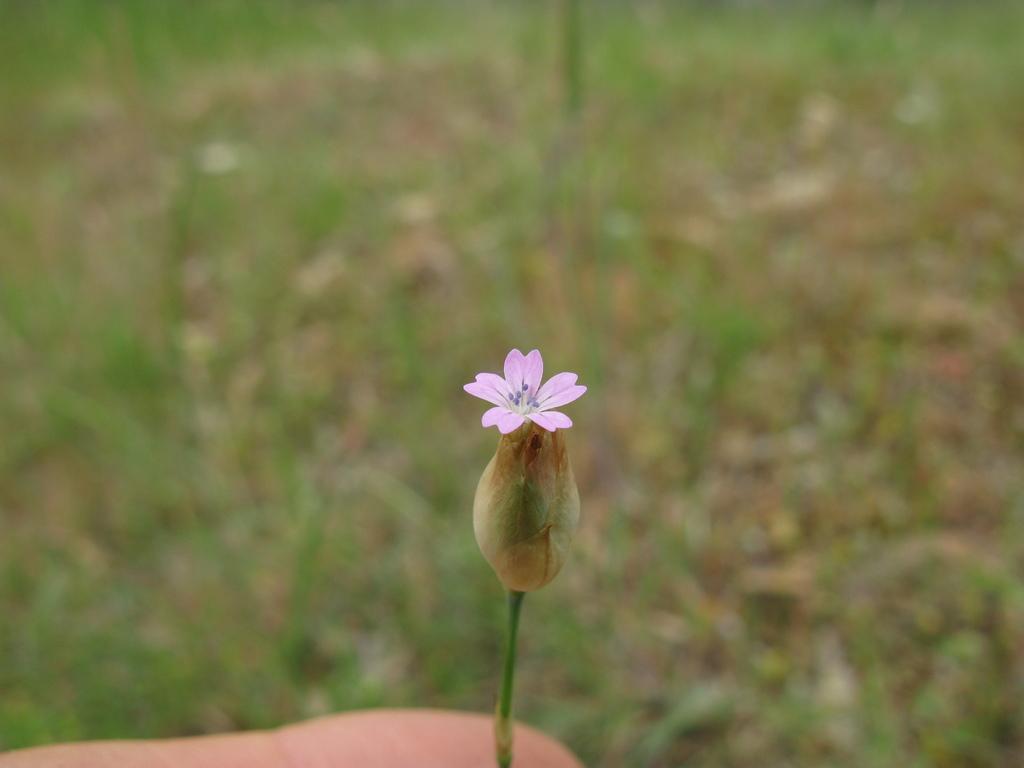Could you give a brief overview of what you see in this image? In this image I can see a purple color flower. Background is in green color and it is blurred. 